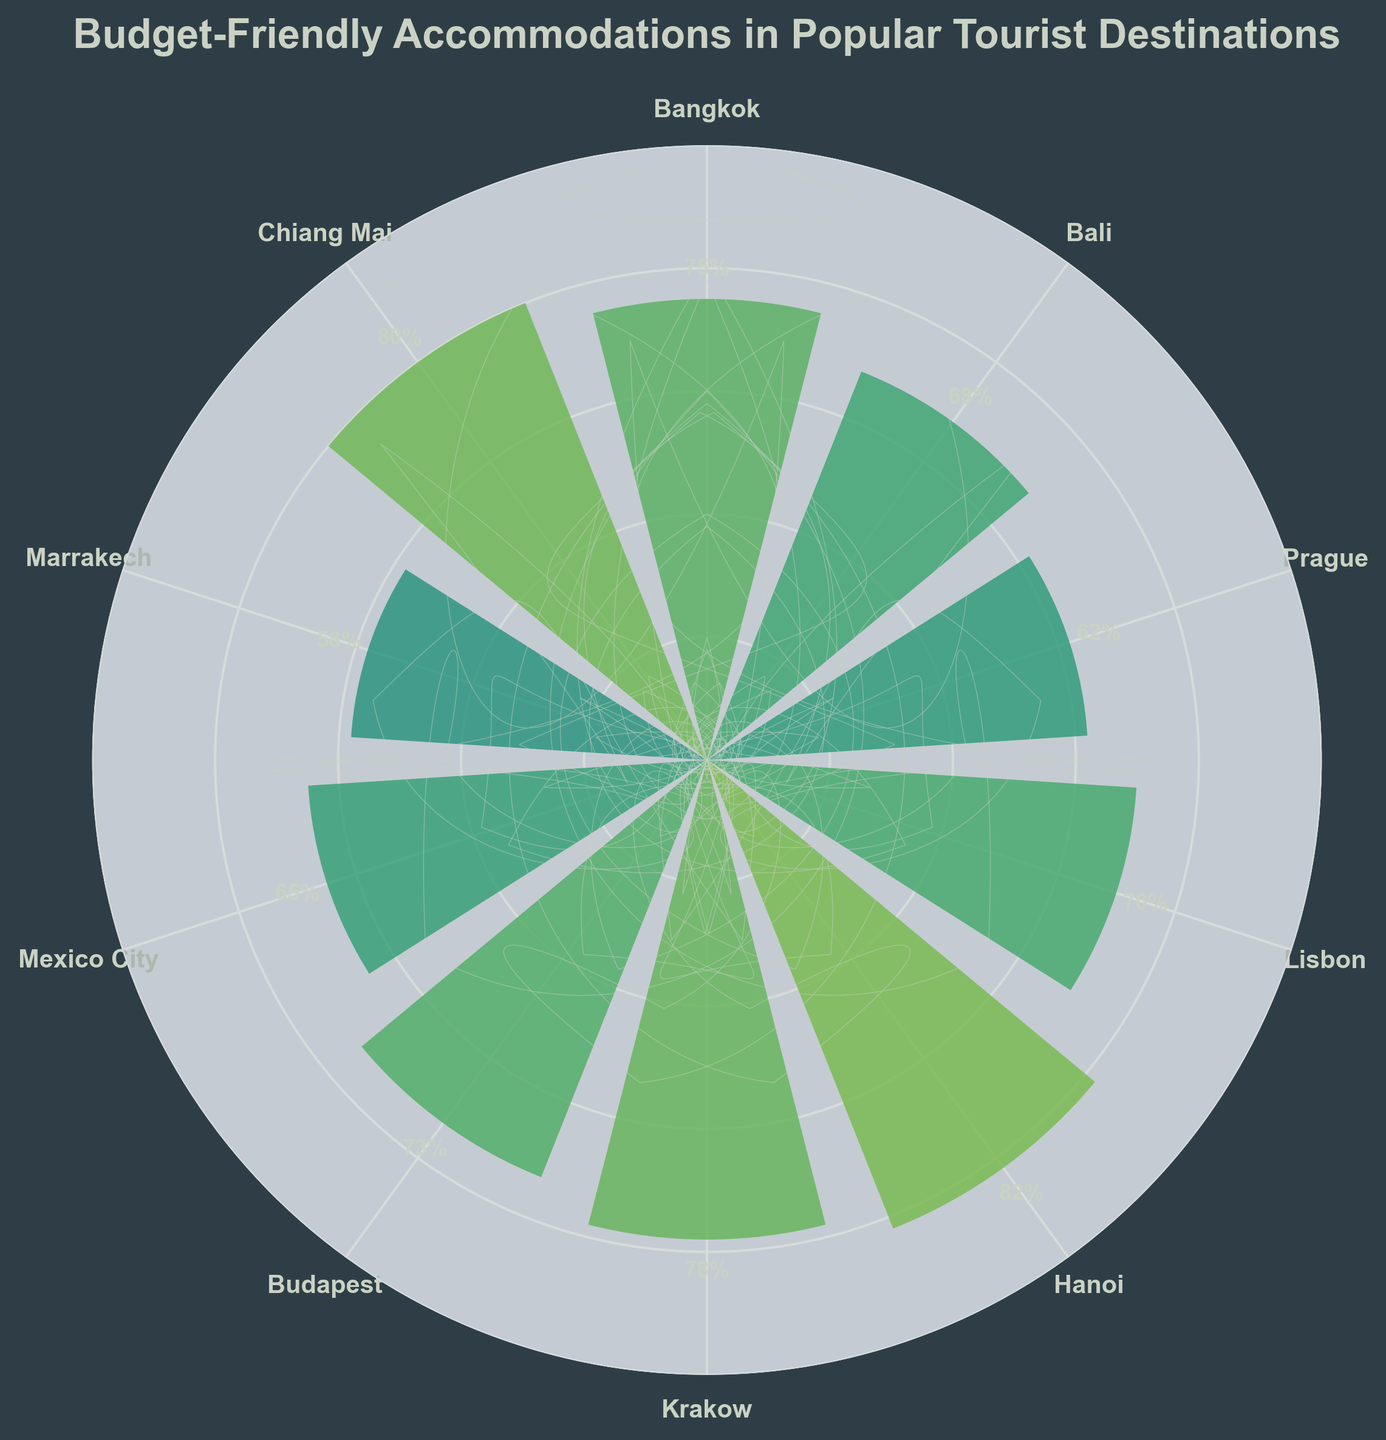What is the title of the chart? The title is located at the top of the chart and is generally bold and larger in font size. The text reads "Budget-Friendly Accommodations in Popular Tourist Destinations" which describes the subject of the chart.
Answer: Budget-Friendly Accommodations in Popular Tourist Destinations How many tourist destinations are shown in the chart? The chart contains labeled sections for each destination. By counting the labels around the circle, you can see that there are 10 tourist destinations displayed.
Answer: 10 Which destination has the highest percentage of budget-friendly accommodations? The highest bar extends the furthest from the center of the gauge. By observing the lengths, Hanoi has the highest value at 82%.
Answer: Hanoi Which destinations have more than 75% budget-friendly accommodations? First, identify the bars that extend beyond the 75% mark. According to the chart, Bangkok, Krakow, Hanoi, and Chiang Mai have percentages higher than 75%.
Answer: Bangkok, Krakow, Hanoi, Chiang Mai What's the average percentage of budget-friendly accommodations across all destinations? To calculate the average, sum the percentages of all destinations and divide by the number of destinations: (75 + 68 + 62 + 70 + 82 + 78 + 73 + 65 + 58 + 80) / 10 = 71.1.
Answer: 71.1 Which destination has the lowest percentage of budget-friendly accommodations? The lowest bar is closest to the center. Marrakech has the lowest percentage at 58%.
Answer: Marrakech What's the difference in percentage points between the destination with the highest and lowest budget-friendly accommodations? Subtract the smallest percentage from the largest percentage: 82% (Hanoi) - 58% (Marrakech) = 24 percentage points.
Answer: 24 percentage points Compare Budapest and Prague: which has a higher percentage of budget-friendly accommodations? By observing the lengths of the bars for these two destinations, Budapest (73%) has a higher percentage than Prague (62%).
Answer: Budapest What is the median percentage of budget-friendly accommodations? List the percentages in order: 58, 62, 65, 68, 70, 73, 75, 78, 80, 82. The middle values are 70 and 73, so the median is (70 + 73) / 2 = 71.5.
Answer: 71.5 How many destinations have a percentage of 70% or higher? Count the bars that reach or exceed the 70% mark. They are: Lisbon, Hanoi, Bangkok, Budapest, Krakow, and Chiang Mai (6 destinations).
Answer: 6 